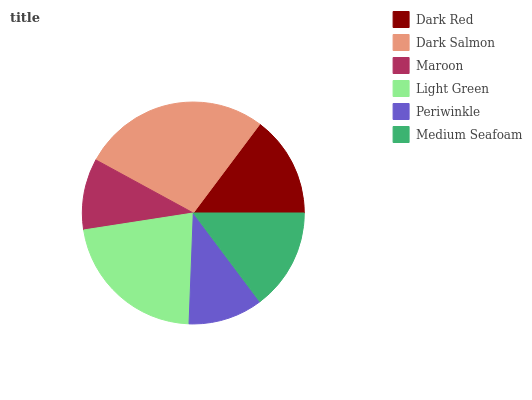Is Maroon the minimum?
Answer yes or no. Yes. Is Dark Salmon the maximum?
Answer yes or no. Yes. Is Dark Salmon the minimum?
Answer yes or no. No. Is Maroon the maximum?
Answer yes or no. No. Is Dark Salmon greater than Maroon?
Answer yes or no. Yes. Is Maroon less than Dark Salmon?
Answer yes or no. Yes. Is Maroon greater than Dark Salmon?
Answer yes or no. No. Is Dark Salmon less than Maroon?
Answer yes or no. No. Is Dark Red the high median?
Answer yes or no. Yes. Is Medium Seafoam the low median?
Answer yes or no. Yes. Is Medium Seafoam the high median?
Answer yes or no. No. Is Light Green the low median?
Answer yes or no. No. 